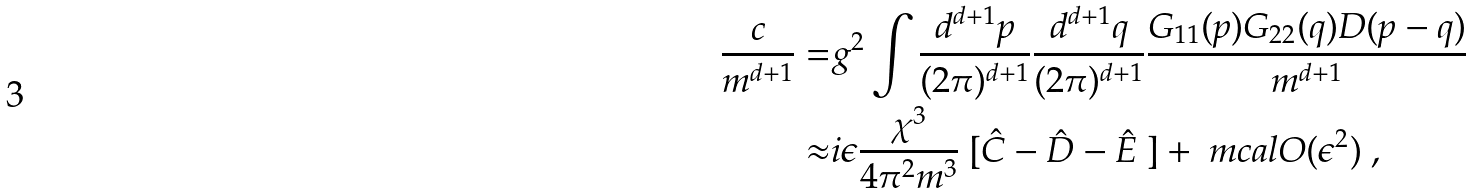Convert formula to latex. <formula><loc_0><loc_0><loc_500><loc_500>\frac { c } { m ^ { d + 1 } } = & g ^ { 2 } \int \frac { d ^ { d + 1 } p } { ( 2 \pi ) ^ { d + 1 } } \frac { d ^ { d + 1 } q } { ( 2 \pi ) ^ { d + 1 } } \frac { G _ { 1 1 } ( p ) G _ { 2 2 } ( q ) D ( p - q ) } { m ^ { d + 1 } } \\ \approx & i \epsilon \frac { \chi ^ { 3 } } { 4 \pi ^ { 2 } m ^ { 3 } } \ [ \hat { C } - \hat { D } - \hat { E } \ ] + \ m c a l O ( \epsilon ^ { 2 } ) \ ,</formula> 